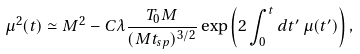Convert formula to latex. <formula><loc_0><loc_0><loc_500><loc_500>\mu ^ { 2 } ( t ) \simeq M ^ { 2 } - C \lambda \frac { T _ { 0 } M } { ( M t _ { s p } ) ^ { 3 / 2 } } \exp \left ( 2 \int _ { 0 } ^ { t } d t ^ { \prime } \, \mu ( t ^ { \prime } ) \right ) ,</formula> 